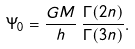Convert formula to latex. <formula><loc_0><loc_0><loc_500><loc_500>\Psi _ { 0 } = \frac { G M } { h } \, \frac { \Gamma ( 2 n ) } { \Gamma ( 3 n ) } .</formula> 